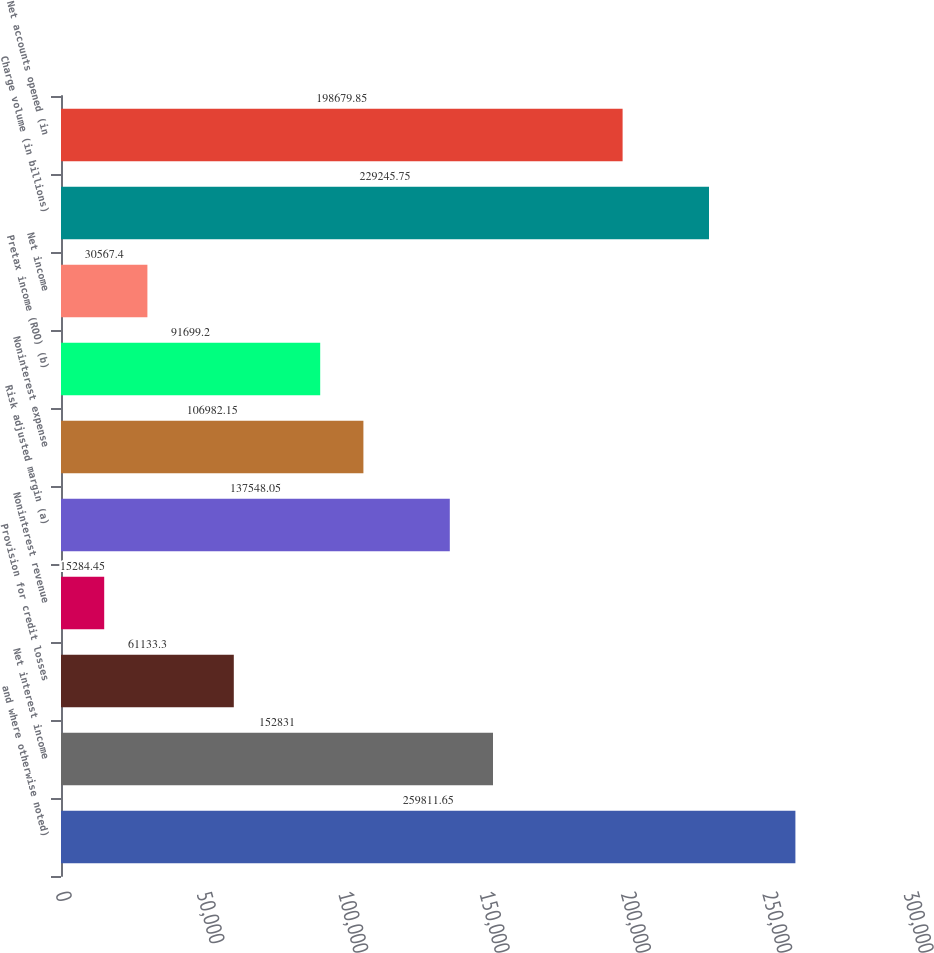Convert chart to OTSL. <chart><loc_0><loc_0><loc_500><loc_500><bar_chart><fcel>and where otherwise noted)<fcel>Net interest income<fcel>Provision for credit losses<fcel>Noninterest revenue<fcel>Risk adjusted margin (a)<fcel>Noninterest expense<fcel>Pretax income (ROO) (b)<fcel>Net income<fcel>Charge volume (in billions)<fcel>Net accounts opened (in<nl><fcel>259812<fcel>152831<fcel>61133.3<fcel>15284.5<fcel>137548<fcel>106982<fcel>91699.2<fcel>30567.4<fcel>229246<fcel>198680<nl></chart> 